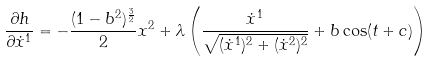<formula> <loc_0><loc_0><loc_500><loc_500>\frac { \partial h } { \partial \dot { x } ^ { 1 } } = - \frac { ( 1 - b ^ { 2 } ) ^ { \frac { 3 } { 2 } } } { 2 } x ^ { 2 } + \lambda \left ( \frac { \dot { x } ^ { 1 } } { \sqrt { ( \dot { x } ^ { 1 } ) ^ { 2 } + ( \dot { x } ^ { 2 } ) ^ { 2 } } } + b \cos ( t + c ) \right )</formula> 